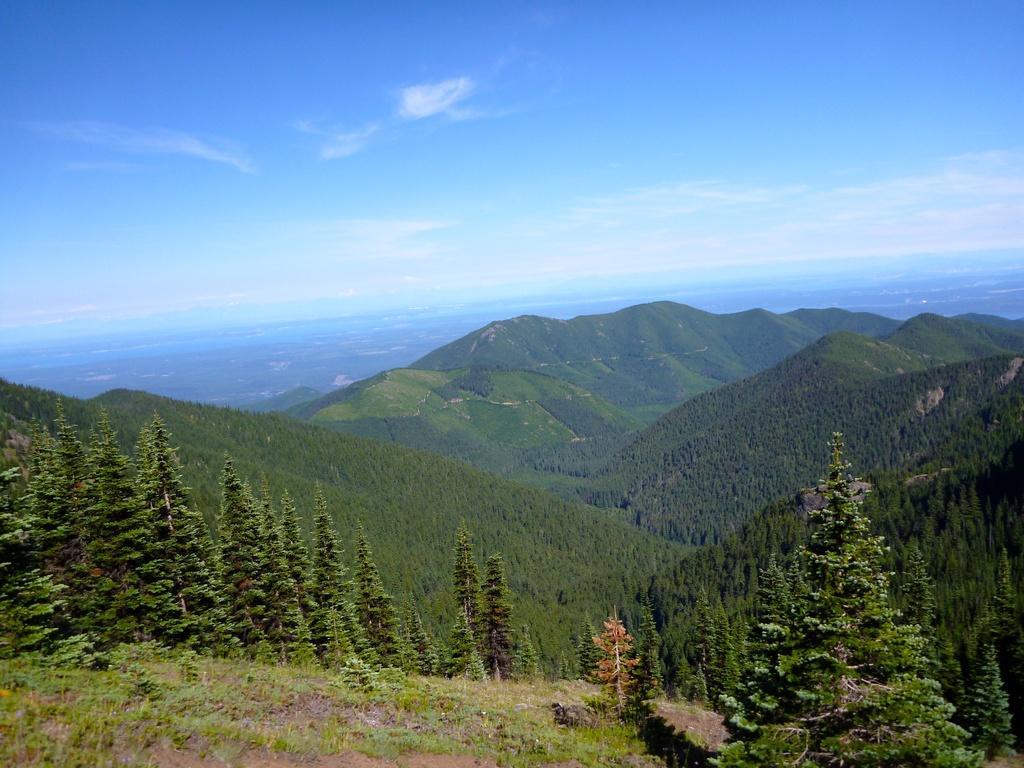Can you describe this image briefly? At the bottom of the picture, we see grass. In the middle of the picture, we see trees. There are trees and hills in the background. At the top of the picture, we see the sky, which is blue in color. 